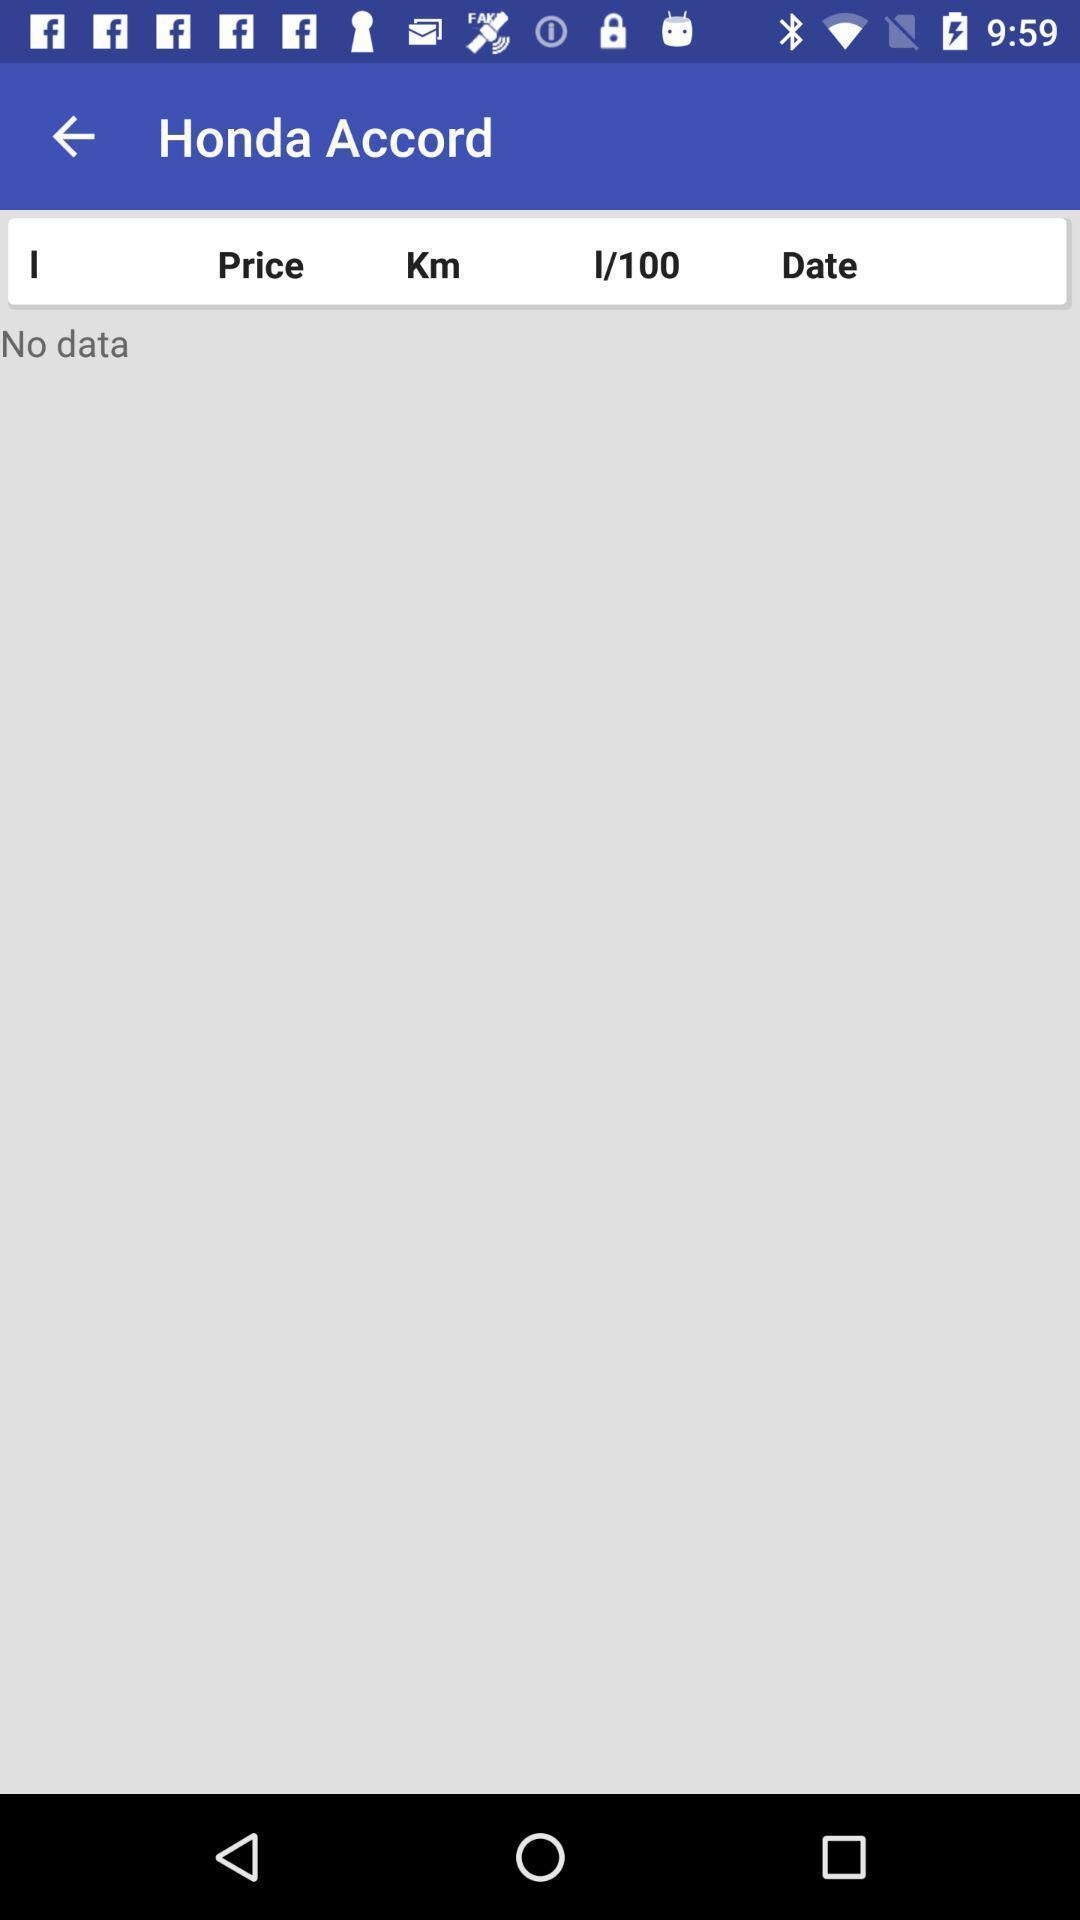Tell me about the visual elements in this screen capture. Vehicle brand displaying in this page. 